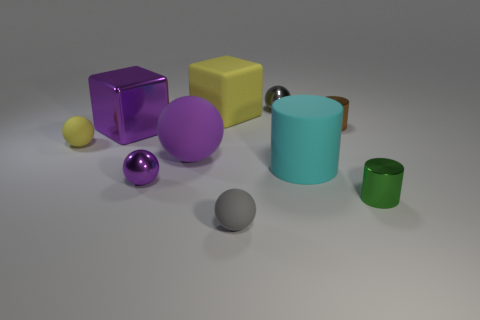Are there fewer rubber things than matte cylinders?
Your response must be concise. No. What is the material of the purple thing that is both behind the cyan rubber object and right of the purple block?
Ensure brevity in your answer.  Rubber. Is there a gray rubber thing behind the purple sphere in front of the large cylinder?
Ensure brevity in your answer.  No. How many things are either tiny yellow balls or tiny gray metallic cylinders?
Your response must be concise. 1. What is the shape of the small object that is both right of the small gray metal ball and behind the green object?
Your answer should be very brief. Cylinder. Are the cylinder behind the cyan thing and the large yellow object made of the same material?
Provide a short and direct response. No. What number of objects are either gray metal cubes or yellow matte objects on the left side of the large yellow rubber block?
Give a very brief answer. 1. What is the color of the other cylinder that is made of the same material as the green cylinder?
Give a very brief answer. Brown. How many purple cylinders have the same material as the tiny green cylinder?
Offer a very short reply. 0. What number of tiny rubber things are there?
Make the answer very short. 2. 